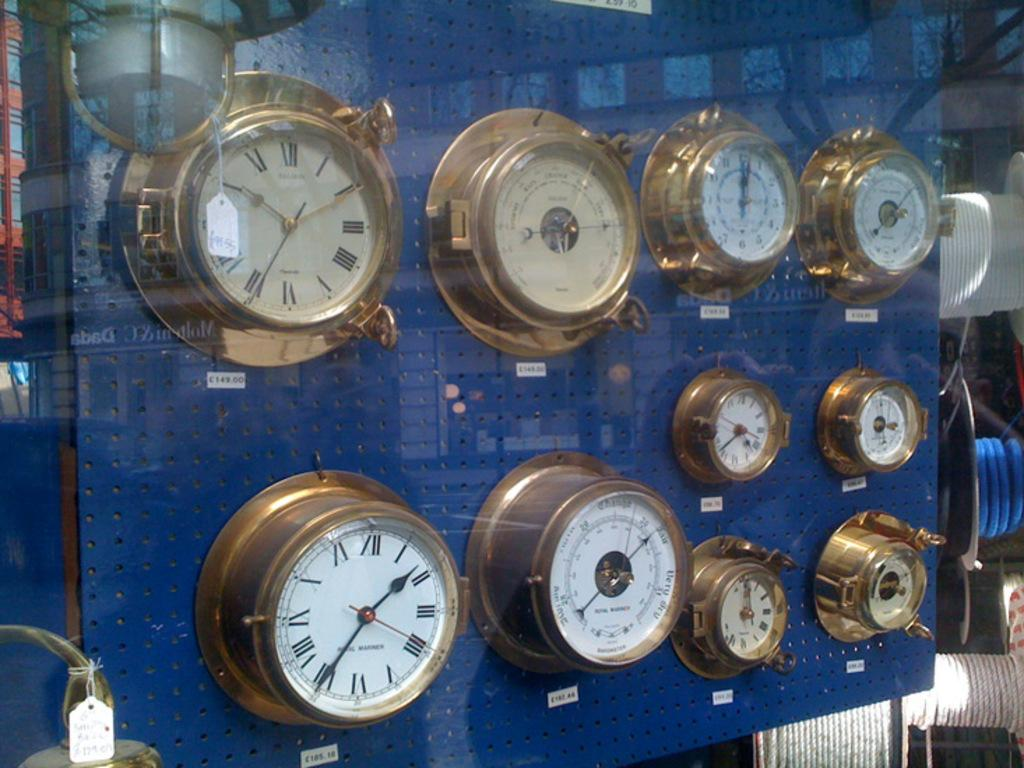Provide a one-sentence caption for the provided image. Old fashioned clocks on display for sale in British pounds for 149.00 and 185.18. 